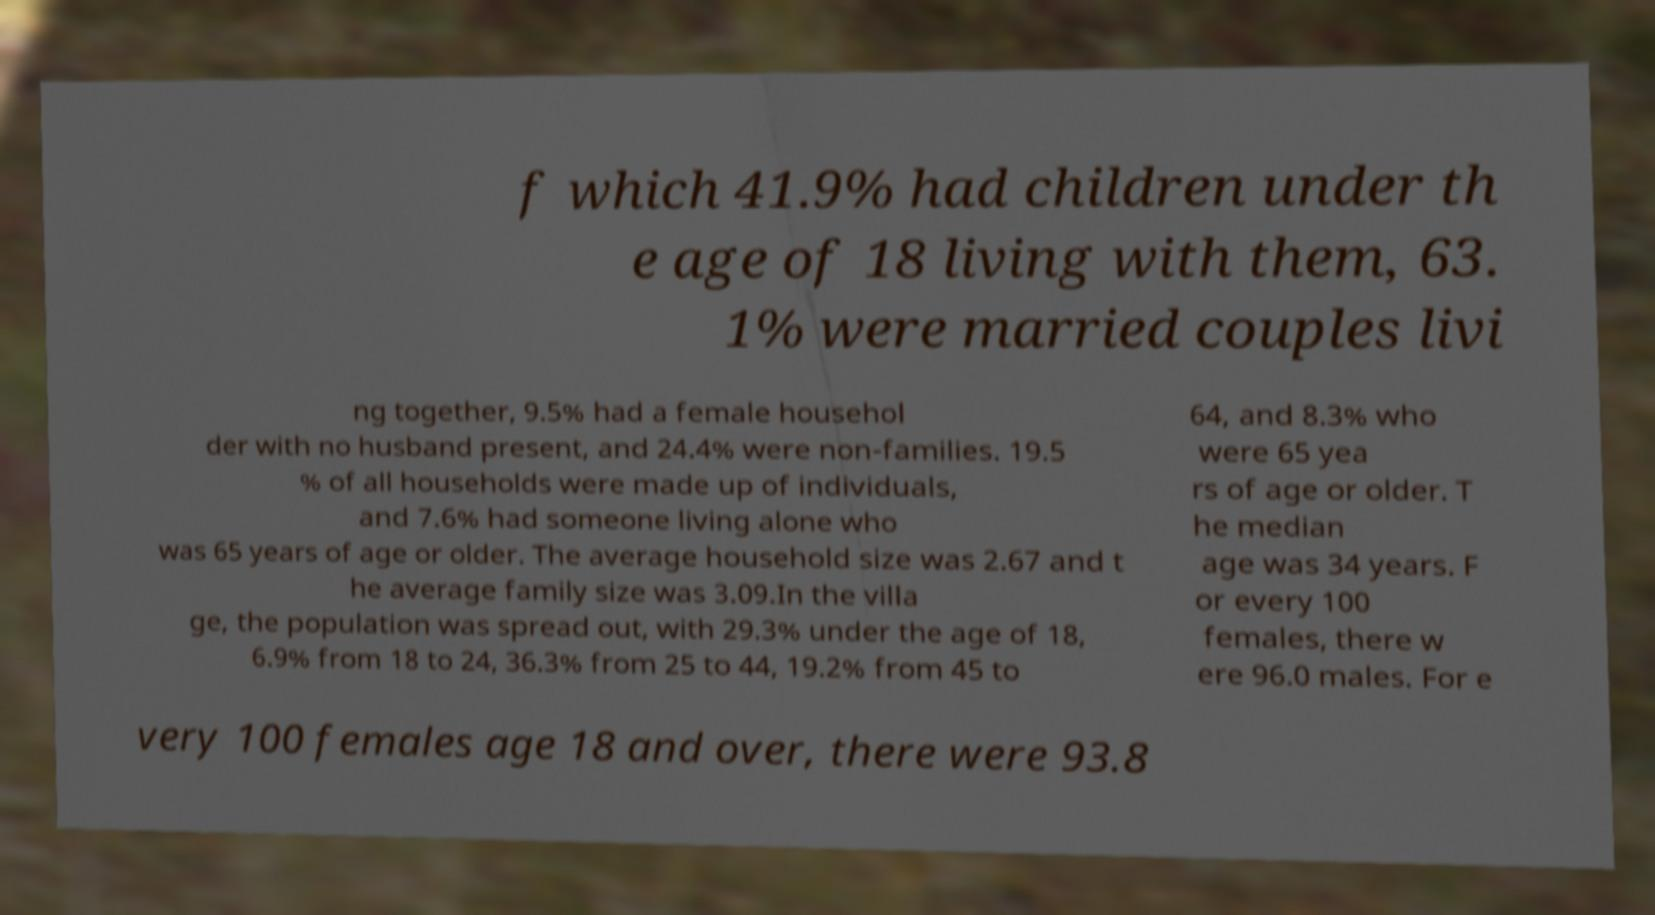There's text embedded in this image that I need extracted. Can you transcribe it verbatim? f which 41.9% had children under th e age of 18 living with them, 63. 1% were married couples livi ng together, 9.5% had a female househol der with no husband present, and 24.4% were non-families. 19.5 % of all households were made up of individuals, and 7.6% had someone living alone who was 65 years of age or older. The average household size was 2.67 and t he average family size was 3.09.In the villa ge, the population was spread out, with 29.3% under the age of 18, 6.9% from 18 to 24, 36.3% from 25 to 44, 19.2% from 45 to 64, and 8.3% who were 65 yea rs of age or older. T he median age was 34 years. F or every 100 females, there w ere 96.0 males. For e very 100 females age 18 and over, there were 93.8 